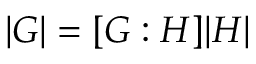<formula> <loc_0><loc_0><loc_500><loc_500>| G | = [ G \colon H ] | H |</formula> 